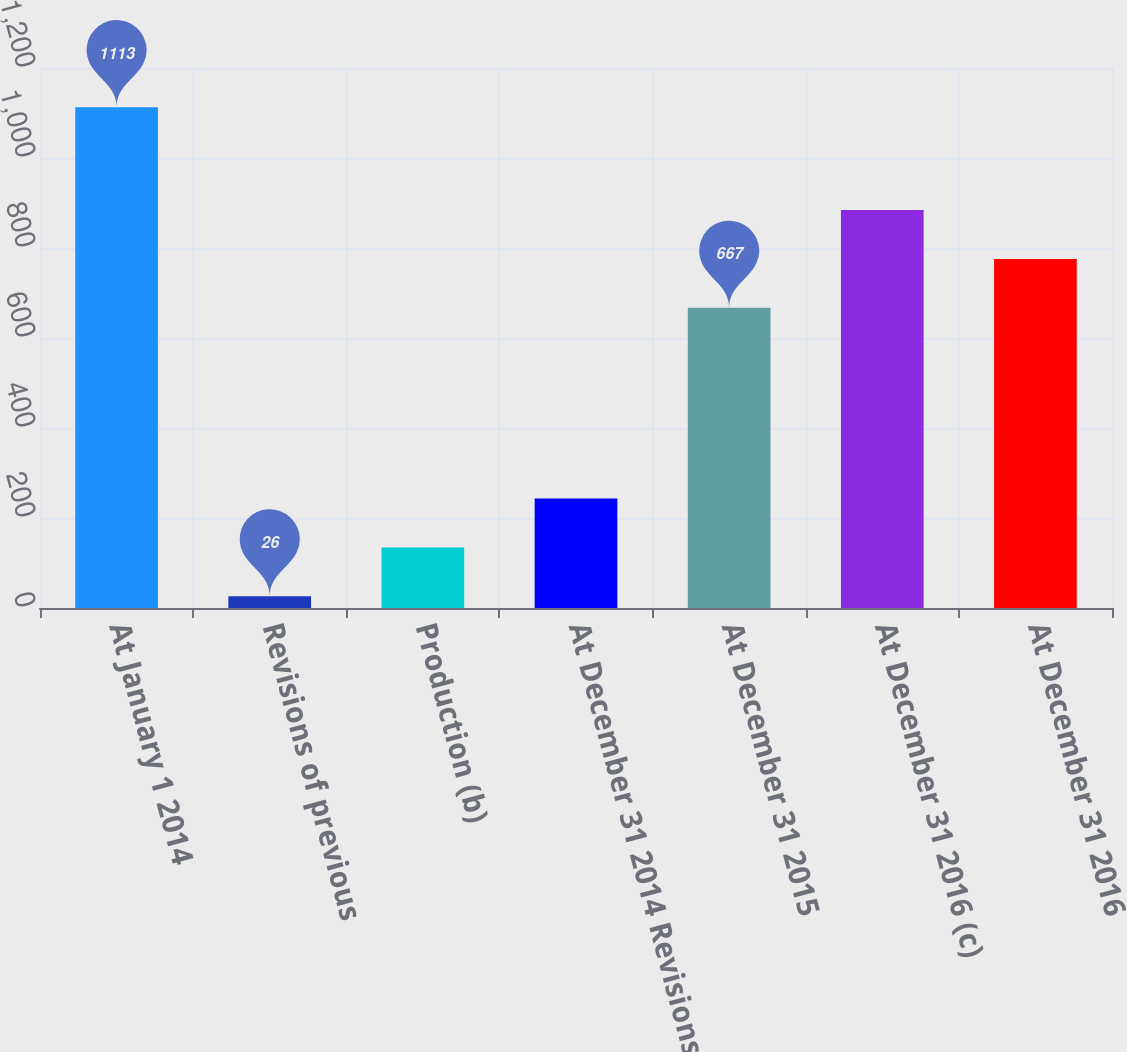Convert chart to OTSL. <chart><loc_0><loc_0><loc_500><loc_500><bar_chart><fcel>At January 1 2014<fcel>Revisions of previous<fcel>Production (b)<fcel>At December 31 2014 Revisions<fcel>At December 31 2015<fcel>At December 31 2016 (c)<fcel>At December 31 2016<nl><fcel>1113<fcel>26<fcel>134.7<fcel>243.4<fcel>667<fcel>884.4<fcel>775.7<nl></chart> 